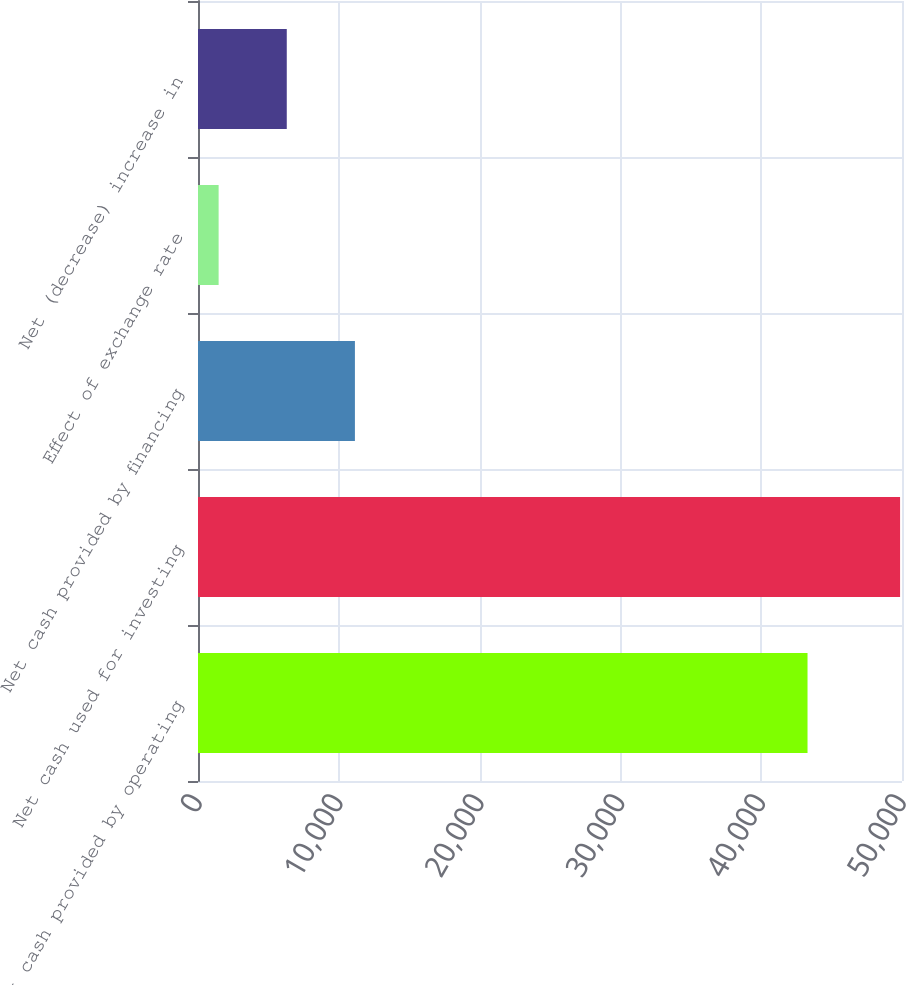Convert chart. <chart><loc_0><loc_0><loc_500><loc_500><bar_chart><fcel>Net cash provided by operating<fcel>Net cash used for investing<fcel>Net cash provided by financing<fcel>Effect of exchange rate<fcel>Net (decrease) increase in<nl><fcel>43290<fcel>49863<fcel>11144.6<fcel>1465<fcel>6304.8<nl></chart> 